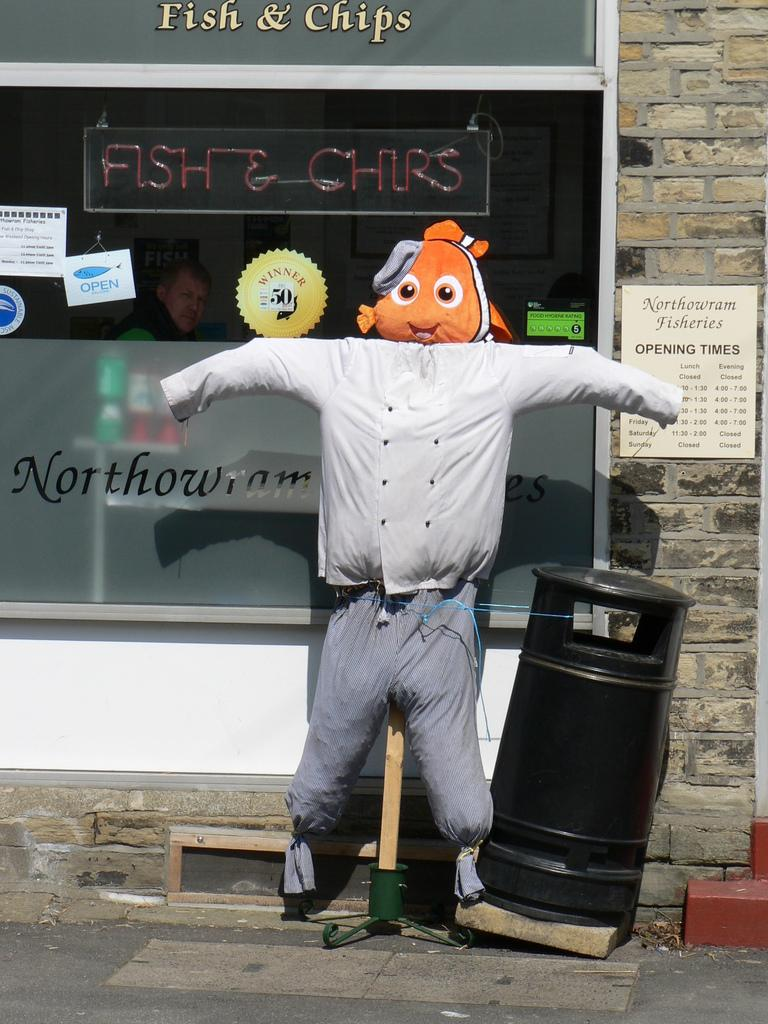Provide a one-sentence caption for the provided image. A scarecrow with a stuffed fish for a head is under a sign that says Fish & Chips. 